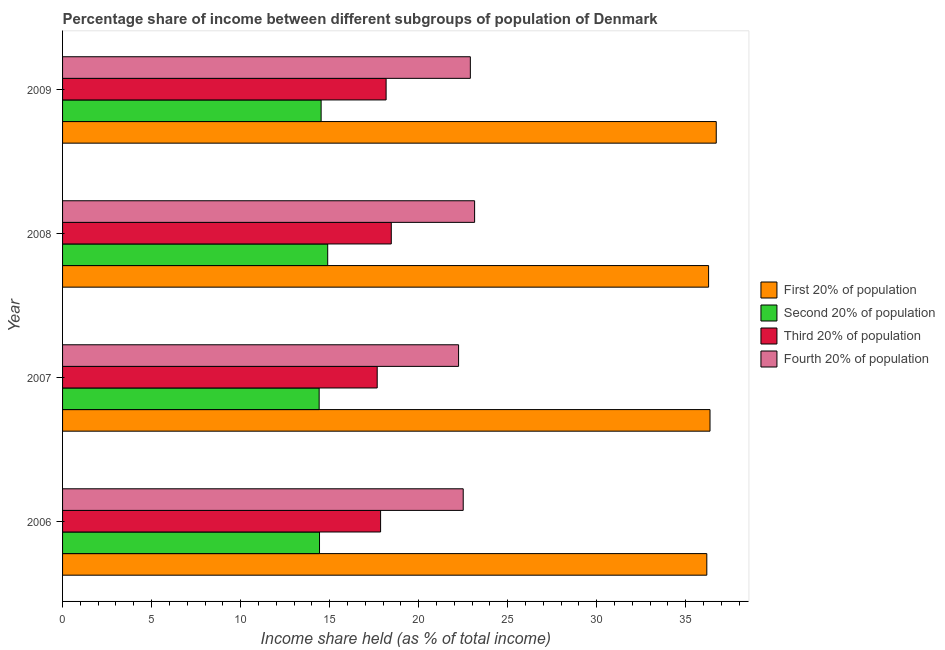How many groups of bars are there?
Make the answer very short. 4. Are the number of bars per tick equal to the number of legend labels?
Keep it short and to the point. Yes. Are the number of bars on each tick of the Y-axis equal?
Provide a succinct answer. Yes. How many bars are there on the 4th tick from the top?
Make the answer very short. 4. How many bars are there on the 4th tick from the bottom?
Make the answer very short. 4. What is the label of the 4th group of bars from the top?
Keep it short and to the point. 2006. In how many cases, is the number of bars for a given year not equal to the number of legend labels?
Your answer should be compact. 0. What is the share of the income held by fourth 20% of the population in 2008?
Provide a short and direct response. 23.14. Across all years, what is the maximum share of the income held by fourth 20% of the population?
Your response must be concise. 23.14. Across all years, what is the minimum share of the income held by fourth 20% of the population?
Provide a short and direct response. 22.24. In which year was the share of the income held by third 20% of the population maximum?
Make the answer very short. 2008. In which year was the share of the income held by second 20% of the population minimum?
Your answer should be compact. 2007. What is the total share of the income held by first 20% of the population in the graph?
Your answer should be very brief. 145.53. What is the difference between the share of the income held by fourth 20% of the population in 2007 and that in 2008?
Your response must be concise. -0.9. What is the difference between the share of the income held by third 20% of the population in 2008 and the share of the income held by second 20% of the population in 2009?
Offer a very short reply. 3.94. What is the average share of the income held by second 20% of the population per year?
Offer a very short reply. 14.56. In the year 2009, what is the difference between the share of the income held by third 20% of the population and share of the income held by second 20% of the population?
Keep it short and to the point. 3.65. In how many years, is the share of the income held by third 20% of the population greater than 11 %?
Ensure brevity in your answer.  4. What is the ratio of the share of the income held by third 20% of the population in 2006 to that in 2008?
Keep it short and to the point. 0.97. What is the difference between the highest and the second highest share of the income held by second 20% of the population?
Provide a short and direct response. 0.37. What is the difference between the highest and the lowest share of the income held by second 20% of the population?
Keep it short and to the point. 0.48. In how many years, is the share of the income held by fourth 20% of the population greater than the average share of the income held by fourth 20% of the population taken over all years?
Make the answer very short. 2. What does the 3rd bar from the top in 2008 represents?
Your response must be concise. Second 20% of population. What does the 4th bar from the bottom in 2008 represents?
Your answer should be compact. Fourth 20% of population. How many years are there in the graph?
Provide a succinct answer. 4. What is the difference between two consecutive major ticks on the X-axis?
Provide a short and direct response. 5. Are the values on the major ticks of X-axis written in scientific E-notation?
Offer a terse response. No. Does the graph contain any zero values?
Offer a very short reply. No. Does the graph contain grids?
Make the answer very short. No. How are the legend labels stacked?
Keep it short and to the point. Vertical. What is the title of the graph?
Provide a succinct answer. Percentage share of income between different subgroups of population of Denmark. Does "Other greenhouse gases" appear as one of the legend labels in the graph?
Your answer should be compact. No. What is the label or title of the X-axis?
Give a very brief answer. Income share held (as % of total income). What is the Income share held (as % of total income) in First 20% of population in 2006?
Give a very brief answer. 36.18. What is the Income share held (as % of total income) in Second 20% of population in 2006?
Your answer should be compact. 14.43. What is the Income share held (as % of total income) in Third 20% of population in 2006?
Provide a succinct answer. 17.86. What is the Income share held (as % of total income) of First 20% of population in 2007?
Offer a very short reply. 36.36. What is the Income share held (as % of total income) of Second 20% of population in 2007?
Offer a very short reply. 14.41. What is the Income share held (as % of total income) in Third 20% of population in 2007?
Offer a terse response. 17.67. What is the Income share held (as % of total income) in Fourth 20% of population in 2007?
Your answer should be compact. 22.24. What is the Income share held (as % of total income) of First 20% of population in 2008?
Provide a succinct answer. 36.28. What is the Income share held (as % of total income) in Second 20% of population in 2008?
Your answer should be very brief. 14.89. What is the Income share held (as % of total income) of Third 20% of population in 2008?
Ensure brevity in your answer.  18.46. What is the Income share held (as % of total income) in Fourth 20% of population in 2008?
Your answer should be very brief. 23.14. What is the Income share held (as % of total income) in First 20% of population in 2009?
Your answer should be compact. 36.71. What is the Income share held (as % of total income) of Second 20% of population in 2009?
Give a very brief answer. 14.52. What is the Income share held (as % of total income) of Third 20% of population in 2009?
Make the answer very short. 18.17. What is the Income share held (as % of total income) in Fourth 20% of population in 2009?
Your answer should be compact. 22.9. Across all years, what is the maximum Income share held (as % of total income) in First 20% of population?
Provide a succinct answer. 36.71. Across all years, what is the maximum Income share held (as % of total income) of Second 20% of population?
Ensure brevity in your answer.  14.89. Across all years, what is the maximum Income share held (as % of total income) in Third 20% of population?
Offer a terse response. 18.46. Across all years, what is the maximum Income share held (as % of total income) in Fourth 20% of population?
Your response must be concise. 23.14. Across all years, what is the minimum Income share held (as % of total income) in First 20% of population?
Keep it short and to the point. 36.18. Across all years, what is the minimum Income share held (as % of total income) in Second 20% of population?
Provide a succinct answer. 14.41. Across all years, what is the minimum Income share held (as % of total income) of Third 20% of population?
Offer a very short reply. 17.67. Across all years, what is the minimum Income share held (as % of total income) in Fourth 20% of population?
Provide a short and direct response. 22.24. What is the total Income share held (as % of total income) of First 20% of population in the graph?
Keep it short and to the point. 145.53. What is the total Income share held (as % of total income) of Second 20% of population in the graph?
Ensure brevity in your answer.  58.25. What is the total Income share held (as % of total income) of Third 20% of population in the graph?
Give a very brief answer. 72.16. What is the total Income share held (as % of total income) of Fourth 20% of population in the graph?
Your answer should be compact. 90.78. What is the difference between the Income share held (as % of total income) in First 20% of population in 2006 and that in 2007?
Your answer should be compact. -0.18. What is the difference between the Income share held (as % of total income) in Second 20% of population in 2006 and that in 2007?
Provide a succinct answer. 0.02. What is the difference between the Income share held (as % of total income) of Third 20% of population in 2006 and that in 2007?
Ensure brevity in your answer.  0.19. What is the difference between the Income share held (as % of total income) in Fourth 20% of population in 2006 and that in 2007?
Keep it short and to the point. 0.26. What is the difference between the Income share held (as % of total income) in First 20% of population in 2006 and that in 2008?
Your response must be concise. -0.1. What is the difference between the Income share held (as % of total income) in Second 20% of population in 2006 and that in 2008?
Make the answer very short. -0.46. What is the difference between the Income share held (as % of total income) in Fourth 20% of population in 2006 and that in 2008?
Offer a very short reply. -0.64. What is the difference between the Income share held (as % of total income) in First 20% of population in 2006 and that in 2009?
Provide a succinct answer. -0.53. What is the difference between the Income share held (as % of total income) in Second 20% of population in 2006 and that in 2009?
Your response must be concise. -0.09. What is the difference between the Income share held (as % of total income) in Third 20% of population in 2006 and that in 2009?
Provide a short and direct response. -0.31. What is the difference between the Income share held (as % of total income) in Second 20% of population in 2007 and that in 2008?
Provide a succinct answer. -0.48. What is the difference between the Income share held (as % of total income) in Third 20% of population in 2007 and that in 2008?
Your answer should be compact. -0.79. What is the difference between the Income share held (as % of total income) of First 20% of population in 2007 and that in 2009?
Make the answer very short. -0.35. What is the difference between the Income share held (as % of total income) in Second 20% of population in 2007 and that in 2009?
Offer a very short reply. -0.11. What is the difference between the Income share held (as % of total income) in Third 20% of population in 2007 and that in 2009?
Ensure brevity in your answer.  -0.5. What is the difference between the Income share held (as % of total income) of Fourth 20% of population in 2007 and that in 2009?
Offer a terse response. -0.66. What is the difference between the Income share held (as % of total income) of First 20% of population in 2008 and that in 2009?
Make the answer very short. -0.43. What is the difference between the Income share held (as % of total income) in Second 20% of population in 2008 and that in 2009?
Your response must be concise. 0.37. What is the difference between the Income share held (as % of total income) in Third 20% of population in 2008 and that in 2009?
Your response must be concise. 0.29. What is the difference between the Income share held (as % of total income) of Fourth 20% of population in 2008 and that in 2009?
Your response must be concise. 0.24. What is the difference between the Income share held (as % of total income) in First 20% of population in 2006 and the Income share held (as % of total income) in Second 20% of population in 2007?
Offer a very short reply. 21.77. What is the difference between the Income share held (as % of total income) of First 20% of population in 2006 and the Income share held (as % of total income) of Third 20% of population in 2007?
Offer a very short reply. 18.51. What is the difference between the Income share held (as % of total income) of First 20% of population in 2006 and the Income share held (as % of total income) of Fourth 20% of population in 2007?
Your response must be concise. 13.94. What is the difference between the Income share held (as % of total income) in Second 20% of population in 2006 and the Income share held (as % of total income) in Third 20% of population in 2007?
Provide a succinct answer. -3.24. What is the difference between the Income share held (as % of total income) of Second 20% of population in 2006 and the Income share held (as % of total income) of Fourth 20% of population in 2007?
Your answer should be very brief. -7.81. What is the difference between the Income share held (as % of total income) of Third 20% of population in 2006 and the Income share held (as % of total income) of Fourth 20% of population in 2007?
Ensure brevity in your answer.  -4.38. What is the difference between the Income share held (as % of total income) of First 20% of population in 2006 and the Income share held (as % of total income) of Second 20% of population in 2008?
Provide a short and direct response. 21.29. What is the difference between the Income share held (as % of total income) in First 20% of population in 2006 and the Income share held (as % of total income) in Third 20% of population in 2008?
Make the answer very short. 17.72. What is the difference between the Income share held (as % of total income) of First 20% of population in 2006 and the Income share held (as % of total income) of Fourth 20% of population in 2008?
Offer a terse response. 13.04. What is the difference between the Income share held (as % of total income) in Second 20% of population in 2006 and the Income share held (as % of total income) in Third 20% of population in 2008?
Your answer should be very brief. -4.03. What is the difference between the Income share held (as % of total income) in Second 20% of population in 2006 and the Income share held (as % of total income) in Fourth 20% of population in 2008?
Provide a short and direct response. -8.71. What is the difference between the Income share held (as % of total income) of Third 20% of population in 2006 and the Income share held (as % of total income) of Fourth 20% of population in 2008?
Your answer should be very brief. -5.28. What is the difference between the Income share held (as % of total income) in First 20% of population in 2006 and the Income share held (as % of total income) in Second 20% of population in 2009?
Offer a terse response. 21.66. What is the difference between the Income share held (as % of total income) of First 20% of population in 2006 and the Income share held (as % of total income) of Third 20% of population in 2009?
Your response must be concise. 18.01. What is the difference between the Income share held (as % of total income) of First 20% of population in 2006 and the Income share held (as % of total income) of Fourth 20% of population in 2009?
Keep it short and to the point. 13.28. What is the difference between the Income share held (as % of total income) of Second 20% of population in 2006 and the Income share held (as % of total income) of Third 20% of population in 2009?
Give a very brief answer. -3.74. What is the difference between the Income share held (as % of total income) of Second 20% of population in 2006 and the Income share held (as % of total income) of Fourth 20% of population in 2009?
Give a very brief answer. -8.47. What is the difference between the Income share held (as % of total income) in Third 20% of population in 2006 and the Income share held (as % of total income) in Fourth 20% of population in 2009?
Keep it short and to the point. -5.04. What is the difference between the Income share held (as % of total income) in First 20% of population in 2007 and the Income share held (as % of total income) in Second 20% of population in 2008?
Keep it short and to the point. 21.47. What is the difference between the Income share held (as % of total income) of First 20% of population in 2007 and the Income share held (as % of total income) of Third 20% of population in 2008?
Offer a very short reply. 17.9. What is the difference between the Income share held (as % of total income) in First 20% of population in 2007 and the Income share held (as % of total income) in Fourth 20% of population in 2008?
Keep it short and to the point. 13.22. What is the difference between the Income share held (as % of total income) in Second 20% of population in 2007 and the Income share held (as % of total income) in Third 20% of population in 2008?
Keep it short and to the point. -4.05. What is the difference between the Income share held (as % of total income) in Second 20% of population in 2007 and the Income share held (as % of total income) in Fourth 20% of population in 2008?
Your response must be concise. -8.73. What is the difference between the Income share held (as % of total income) of Third 20% of population in 2007 and the Income share held (as % of total income) of Fourth 20% of population in 2008?
Give a very brief answer. -5.47. What is the difference between the Income share held (as % of total income) of First 20% of population in 2007 and the Income share held (as % of total income) of Second 20% of population in 2009?
Offer a terse response. 21.84. What is the difference between the Income share held (as % of total income) of First 20% of population in 2007 and the Income share held (as % of total income) of Third 20% of population in 2009?
Offer a terse response. 18.19. What is the difference between the Income share held (as % of total income) in First 20% of population in 2007 and the Income share held (as % of total income) in Fourth 20% of population in 2009?
Your response must be concise. 13.46. What is the difference between the Income share held (as % of total income) in Second 20% of population in 2007 and the Income share held (as % of total income) in Third 20% of population in 2009?
Your answer should be very brief. -3.76. What is the difference between the Income share held (as % of total income) of Second 20% of population in 2007 and the Income share held (as % of total income) of Fourth 20% of population in 2009?
Your response must be concise. -8.49. What is the difference between the Income share held (as % of total income) in Third 20% of population in 2007 and the Income share held (as % of total income) in Fourth 20% of population in 2009?
Your answer should be compact. -5.23. What is the difference between the Income share held (as % of total income) of First 20% of population in 2008 and the Income share held (as % of total income) of Second 20% of population in 2009?
Your response must be concise. 21.76. What is the difference between the Income share held (as % of total income) in First 20% of population in 2008 and the Income share held (as % of total income) in Third 20% of population in 2009?
Your answer should be compact. 18.11. What is the difference between the Income share held (as % of total income) in First 20% of population in 2008 and the Income share held (as % of total income) in Fourth 20% of population in 2009?
Provide a succinct answer. 13.38. What is the difference between the Income share held (as % of total income) in Second 20% of population in 2008 and the Income share held (as % of total income) in Third 20% of population in 2009?
Provide a succinct answer. -3.28. What is the difference between the Income share held (as % of total income) of Second 20% of population in 2008 and the Income share held (as % of total income) of Fourth 20% of population in 2009?
Ensure brevity in your answer.  -8.01. What is the difference between the Income share held (as % of total income) of Third 20% of population in 2008 and the Income share held (as % of total income) of Fourth 20% of population in 2009?
Keep it short and to the point. -4.44. What is the average Income share held (as % of total income) of First 20% of population per year?
Make the answer very short. 36.38. What is the average Income share held (as % of total income) in Second 20% of population per year?
Keep it short and to the point. 14.56. What is the average Income share held (as % of total income) of Third 20% of population per year?
Provide a succinct answer. 18.04. What is the average Income share held (as % of total income) in Fourth 20% of population per year?
Your answer should be very brief. 22.7. In the year 2006, what is the difference between the Income share held (as % of total income) in First 20% of population and Income share held (as % of total income) in Second 20% of population?
Ensure brevity in your answer.  21.75. In the year 2006, what is the difference between the Income share held (as % of total income) in First 20% of population and Income share held (as % of total income) in Third 20% of population?
Your response must be concise. 18.32. In the year 2006, what is the difference between the Income share held (as % of total income) in First 20% of population and Income share held (as % of total income) in Fourth 20% of population?
Ensure brevity in your answer.  13.68. In the year 2006, what is the difference between the Income share held (as % of total income) in Second 20% of population and Income share held (as % of total income) in Third 20% of population?
Your response must be concise. -3.43. In the year 2006, what is the difference between the Income share held (as % of total income) in Second 20% of population and Income share held (as % of total income) in Fourth 20% of population?
Your answer should be compact. -8.07. In the year 2006, what is the difference between the Income share held (as % of total income) of Third 20% of population and Income share held (as % of total income) of Fourth 20% of population?
Give a very brief answer. -4.64. In the year 2007, what is the difference between the Income share held (as % of total income) of First 20% of population and Income share held (as % of total income) of Second 20% of population?
Your answer should be compact. 21.95. In the year 2007, what is the difference between the Income share held (as % of total income) of First 20% of population and Income share held (as % of total income) of Third 20% of population?
Provide a succinct answer. 18.69. In the year 2007, what is the difference between the Income share held (as % of total income) of First 20% of population and Income share held (as % of total income) of Fourth 20% of population?
Ensure brevity in your answer.  14.12. In the year 2007, what is the difference between the Income share held (as % of total income) of Second 20% of population and Income share held (as % of total income) of Third 20% of population?
Ensure brevity in your answer.  -3.26. In the year 2007, what is the difference between the Income share held (as % of total income) in Second 20% of population and Income share held (as % of total income) in Fourth 20% of population?
Keep it short and to the point. -7.83. In the year 2007, what is the difference between the Income share held (as % of total income) in Third 20% of population and Income share held (as % of total income) in Fourth 20% of population?
Ensure brevity in your answer.  -4.57. In the year 2008, what is the difference between the Income share held (as % of total income) in First 20% of population and Income share held (as % of total income) in Second 20% of population?
Offer a very short reply. 21.39. In the year 2008, what is the difference between the Income share held (as % of total income) in First 20% of population and Income share held (as % of total income) in Third 20% of population?
Make the answer very short. 17.82. In the year 2008, what is the difference between the Income share held (as % of total income) in First 20% of population and Income share held (as % of total income) in Fourth 20% of population?
Give a very brief answer. 13.14. In the year 2008, what is the difference between the Income share held (as % of total income) of Second 20% of population and Income share held (as % of total income) of Third 20% of population?
Offer a terse response. -3.57. In the year 2008, what is the difference between the Income share held (as % of total income) of Second 20% of population and Income share held (as % of total income) of Fourth 20% of population?
Your response must be concise. -8.25. In the year 2008, what is the difference between the Income share held (as % of total income) in Third 20% of population and Income share held (as % of total income) in Fourth 20% of population?
Offer a terse response. -4.68. In the year 2009, what is the difference between the Income share held (as % of total income) in First 20% of population and Income share held (as % of total income) in Second 20% of population?
Provide a short and direct response. 22.19. In the year 2009, what is the difference between the Income share held (as % of total income) in First 20% of population and Income share held (as % of total income) in Third 20% of population?
Provide a short and direct response. 18.54. In the year 2009, what is the difference between the Income share held (as % of total income) in First 20% of population and Income share held (as % of total income) in Fourth 20% of population?
Provide a succinct answer. 13.81. In the year 2009, what is the difference between the Income share held (as % of total income) in Second 20% of population and Income share held (as % of total income) in Third 20% of population?
Offer a very short reply. -3.65. In the year 2009, what is the difference between the Income share held (as % of total income) in Second 20% of population and Income share held (as % of total income) in Fourth 20% of population?
Make the answer very short. -8.38. In the year 2009, what is the difference between the Income share held (as % of total income) in Third 20% of population and Income share held (as % of total income) in Fourth 20% of population?
Your answer should be compact. -4.73. What is the ratio of the Income share held (as % of total income) of Second 20% of population in 2006 to that in 2007?
Ensure brevity in your answer.  1. What is the ratio of the Income share held (as % of total income) of Third 20% of population in 2006 to that in 2007?
Offer a very short reply. 1.01. What is the ratio of the Income share held (as % of total income) in Fourth 20% of population in 2006 to that in 2007?
Make the answer very short. 1.01. What is the ratio of the Income share held (as % of total income) of First 20% of population in 2006 to that in 2008?
Offer a very short reply. 1. What is the ratio of the Income share held (as % of total income) in Second 20% of population in 2006 to that in 2008?
Offer a very short reply. 0.97. What is the ratio of the Income share held (as % of total income) in Third 20% of population in 2006 to that in 2008?
Offer a very short reply. 0.97. What is the ratio of the Income share held (as % of total income) of Fourth 20% of population in 2006 to that in 2008?
Your answer should be very brief. 0.97. What is the ratio of the Income share held (as % of total income) of First 20% of population in 2006 to that in 2009?
Provide a short and direct response. 0.99. What is the ratio of the Income share held (as % of total income) in Second 20% of population in 2006 to that in 2009?
Your answer should be compact. 0.99. What is the ratio of the Income share held (as % of total income) of Third 20% of population in 2006 to that in 2009?
Offer a terse response. 0.98. What is the ratio of the Income share held (as % of total income) of Fourth 20% of population in 2006 to that in 2009?
Provide a succinct answer. 0.98. What is the ratio of the Income share held (as % of total income) in Second 20% of population in 2007 to that in 2008?
Make the answer very short. 0.97. What is the ratio of the Income share held (as % of total income) in Third 20% of population in 2007 to that in 2008?
Give a very brief answer. 0.96. What is the ratio of the Income share held (as % of total income) of Fourth 20% of population in 2007 to that in 2008?
Your answer should be compact. 0.96. What is the ratio of the Income share held (as % of total income) in First 20% of population in 2007 to that in 2009?
Provide a succinct answer. 0.99. What is the ratio of the Income share held (as % of total income) in Third 20% of population in 2007 to that in 2009?
Provide a short and direct response. 0.97. What is the ratio of the Income share held (as % of total income) of Fourth 20% of population in 2007 to that in 2009?
Your answer should be very brief. 0.97. What is the ratio of the Income share held (as % of total income) in First 20% of population in 2008 to that in 2009?
Offer a terse response. 0.99. What is the ratio of the Income share held (as % of total income) of Second 20% of population in 2008 to that in 2009?
Give a very brief answer. 1.03. What is the ratio of the Income share held (as % of total income) of Third 20% of population in 2008 to that in 2009?
Keep it short and to the point. 1.02. What is the ratio of the Income share held (as % of total income) of Fourth 20% of population in 2008 to that in 2009?
Ensure brevity in your answer.  1.01. What is the difference between the highest and the second highest Income share held (as % of total income) in Second 20% of population?
Offer a very short reply. 0.37. What is the difference between the highest and the second highest Income share held (as % of total income) in Third 20% of population?
Keep it short and to the point. 0.29. What is the difference between the highest and the second highest Income share held (as % of total income) of Fourth 20% of population?
Offer a terse response. 0.24. What is the difference between the highest and the lowest Income share held (as % of total income) of First 20% of population?
Provide a short and direct response. 0.53. What is the difference between the highest and the lowest Income share held (as % of total income) in Second 20% of population?
Offer a terse response. 0.48. What is the difference between the highest and the lowest Income share held (as % of total income) of Third 20% of population?
Your answer should be very brief. 0.79. 